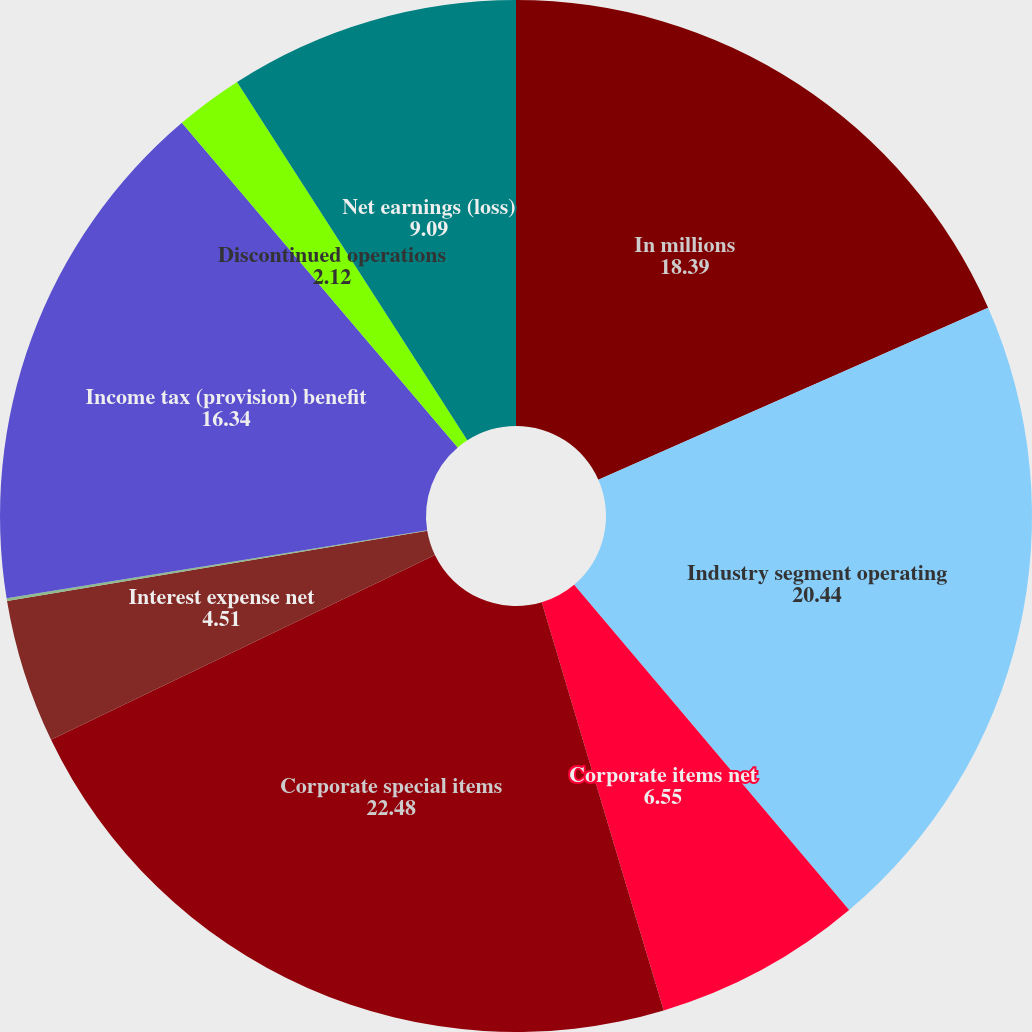Convert chart to OTSL. <chart><loc_0><loc_0><loc_500><loc_500><pie_chart><fcel>In millions<fcel>Industry segment operating<fcel>Corporate items net<fcel>Corporate special items<fcel>Interest expense net<fcel>Minority interest<fcel>Income tax (provision) benefit<fcel>Discontinued operations<fcel>Net earnings (loss)<nl><fcel>18.39%<fcel>20.44%<fcel>6.55%<fcel>22.48%<fcel>4.51%<fcel>0.08%<fcel>16.34%<fcel>2.12%<fcel>9.09%<nl></chart> 